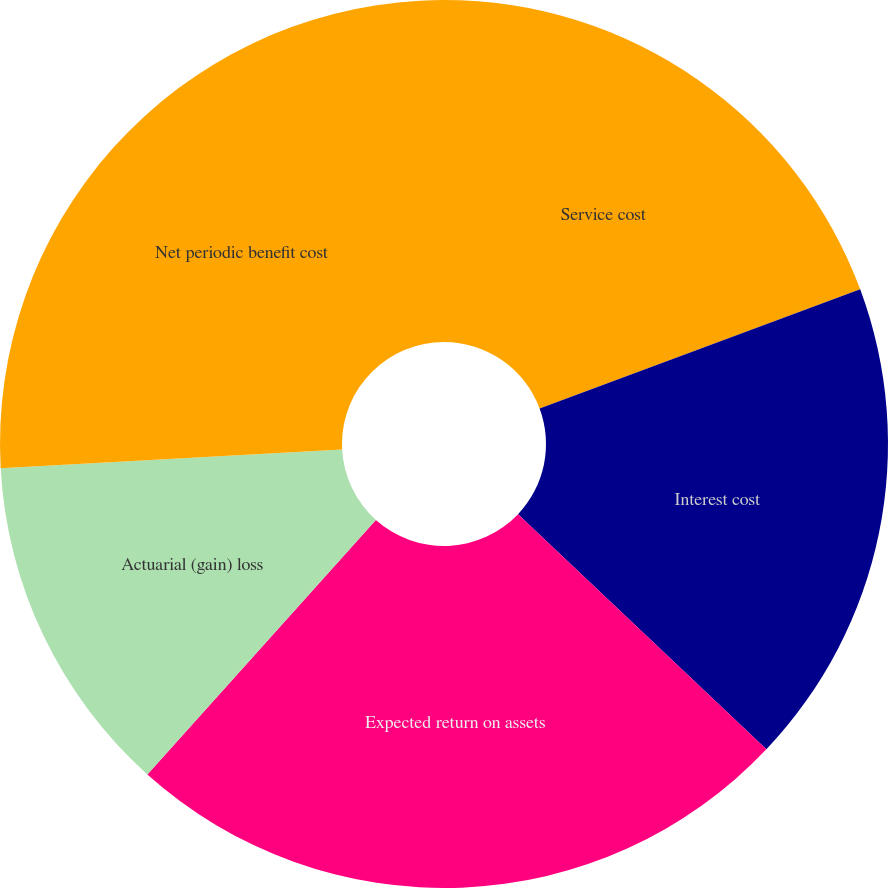Convert chart to OTSL. <chart><loc_0><loc_0><loc_500><loc_500><pie_chart><fcel>Service cost<fcel>Interest cost<fcel>Expected return on assets<fcel>Actuarial (gain) loss<fcel>Net periodic benefit cost<nl><fcel>19.34%<fcel>17.73%<fcel>24.58%<fcel>12.49%<fcel>25.87%<nl></chart> 